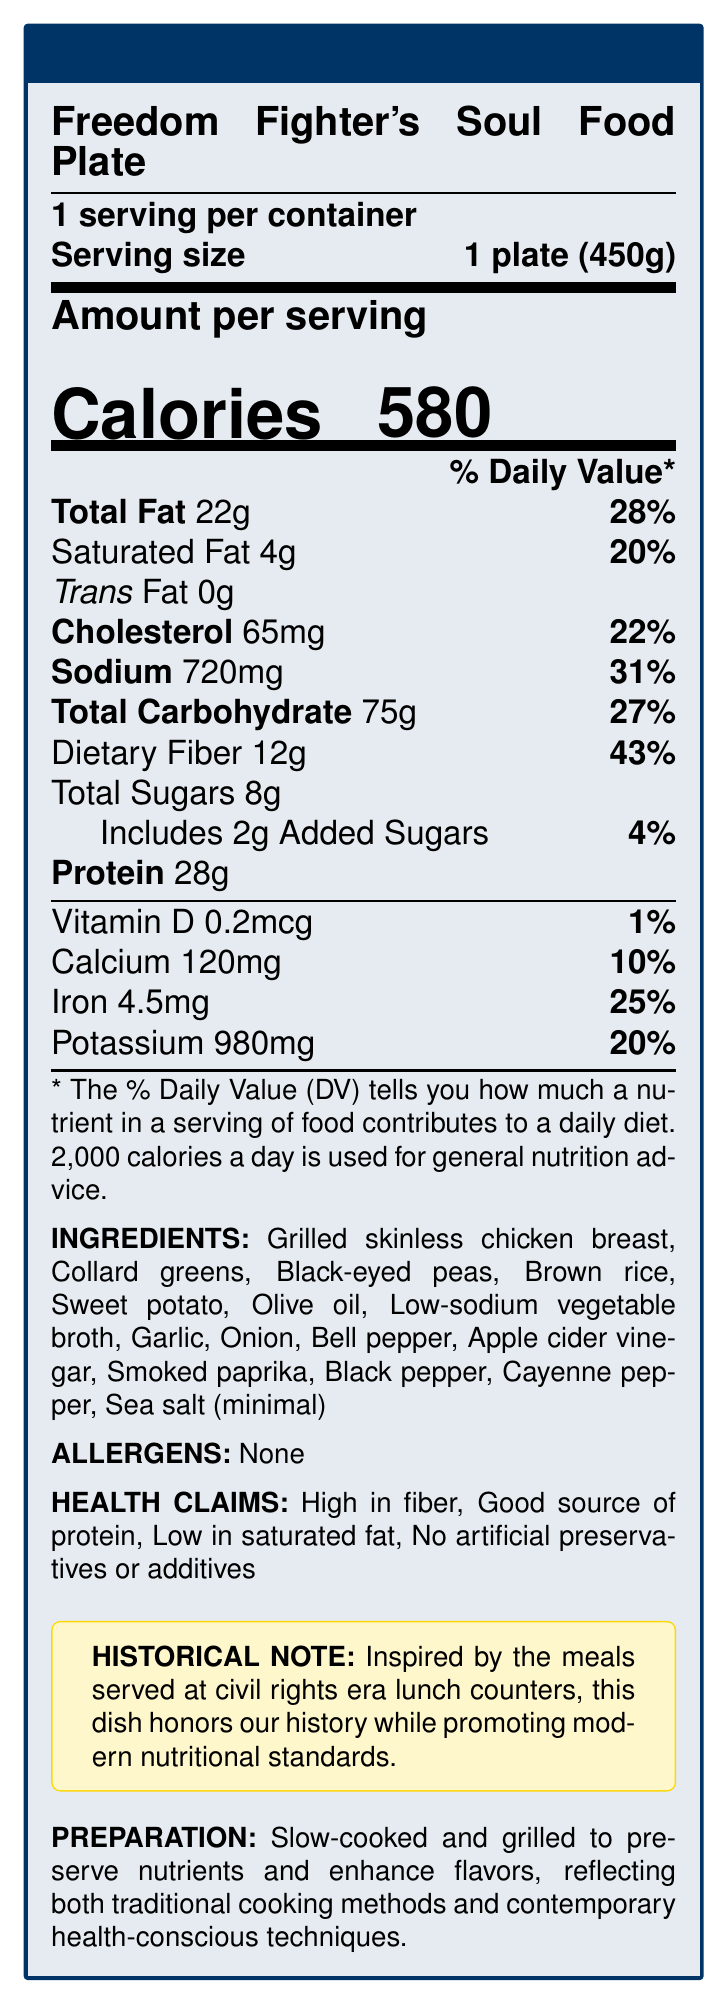what is the serving size of the Freedom Fighter's Soul Food Plate? The serving size is explicitly mentioned in the document as "1 plate (450g)".
Answer: 1 plate (450g) how many calories are in one serving? The document specifies the amount per serving as 580 calories.
Answer: 580 what percentage of the daily value of dietary fiber does one serving provide? The document lists the dietary fiber content as 12g, which contributes 43% to the daily value.
Answer: 43% how much sodium is in one serving, and what percentage of the daily value does it represent? The document indicates that one serving contains 720mg of sodium, accounting for 31% of the daily value.
Answer: 720mg, 31% what are the main ingredients in the Freedom Fighter's Soul Food Plate? The document provides a detailed list of ingredients in the section labeled "INGREDIENTS."
Answer: Grilled skinless chicken breast, Collard greens, Black-eyed peas, Brown rice, Sweet potato, Olive oil, Low-sodium vegetable broth, Garlic, Onion, Bell pepper, Apple cider vinegar, Smoked paprika, Black pepper, Cayenne pepper, Sea salt (minimal) which of the following health claims is NOT listed in the document? A. Low in saturated fat B. High in trans fat C. Good source of protein D. No artificial preservatives or additives The document lists "Low in saturated fat," "Good source of protein," and "No artificial preservatives or additives," but does not mention "High in trans fat."
Answer: B what percentage of the daily value of iron does one serving of this meal provide? The document indicates that one serving provides 25% of the daily value of iron.
Answer: 25% is the Freedom Fighter's Soul Food Plate free from allergens? The document states "None" under the "ALLERGENS" section.
Answer: Yes what preparation methods are used for the Freedom Fighter's Soul Food Plate? A. Frying and microwaving B. Steaming and poaching C. Slow-cooked and grilled D. Raw and blended The document indicates that the dish is "Slow-cooked and grilled" to preserve nutrients and enhance flavors.
Answer: C what is the amount of added sugars per serving? The document specifies that there are 2g of added sugars per serving.
Answer: 2g how does the Freedom Fighter's Soul Food Plate honor history while promoting modern nutritional standards? The document's historical note explains that the dish is inspired by civil rights era meals and adapted to meet modern nutritional guidelines.
Answer: Inspired by the meals served at civil rights era lunch counters, this dish honors our history while promoting modern nutritional standards. what is the total amount of fat in one serving, and what is its daily value percentage? The document lists the total fat content as 22g, which is 28% of the daily value.
Answer: 22g, 28% what is the historical significance of the Freedom Fighter's Soul Food Plate? The "historical note" section states that the meal is inspired by dishes from civil rights era lunch counters and highlights the blend of traditional and modern cooking techniques.
Answer: Inspired by the civil rights era lunch counters. Reflects both traditional and contemporary cooking methods and standards. how much potassium does one serving of this meal provide? The document specifies that one serving provides 980mg of potassium.
Answer: 980mg does the document specify the meal's price? The document does not provide any information about the price of the meal.
Answer: Not enough information summarize the main idea of this nutrition facts label. The document provides comprehensive nutritional details, ingredient list, allergens, health claims, historical context, and preparation methods, highlighting the blend of tradition and modern health consciousness.
Answer: The Freedom Fighter's Soul Food Plate is a healthy meal inspired by civil rights era cuisine, offering detailed nutritional information focusing on its beneficial qualities, such as high fiber and protein content, low saturated fat, and absence of allergens or artificial additives. It honors historical significance while adhering to modern health standards. 